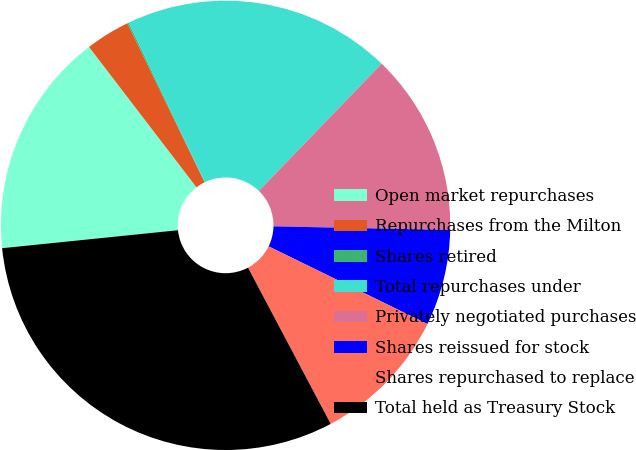Convert chart. <chart><loc_0><loc_0><loc_500><loc_500><pie_chart><fcel>Open market repurchases<fcel>Repurchases from the Milton<fcel>Shares retired<fcel>Total repurchases under<fcel>Privately negotiated purchases<fcel>Shares reissued for stock<fcel>Shares repurchased to replace<fcel>Total held as Treasury Stock<nl><fcel>16.22%<fcel>3.2%<fcel>0.1%<fcel>19.32%<fcel>13.11%<fcel>6.91%<fcel>10.01%<fcel>31.13%<nl></chart> 